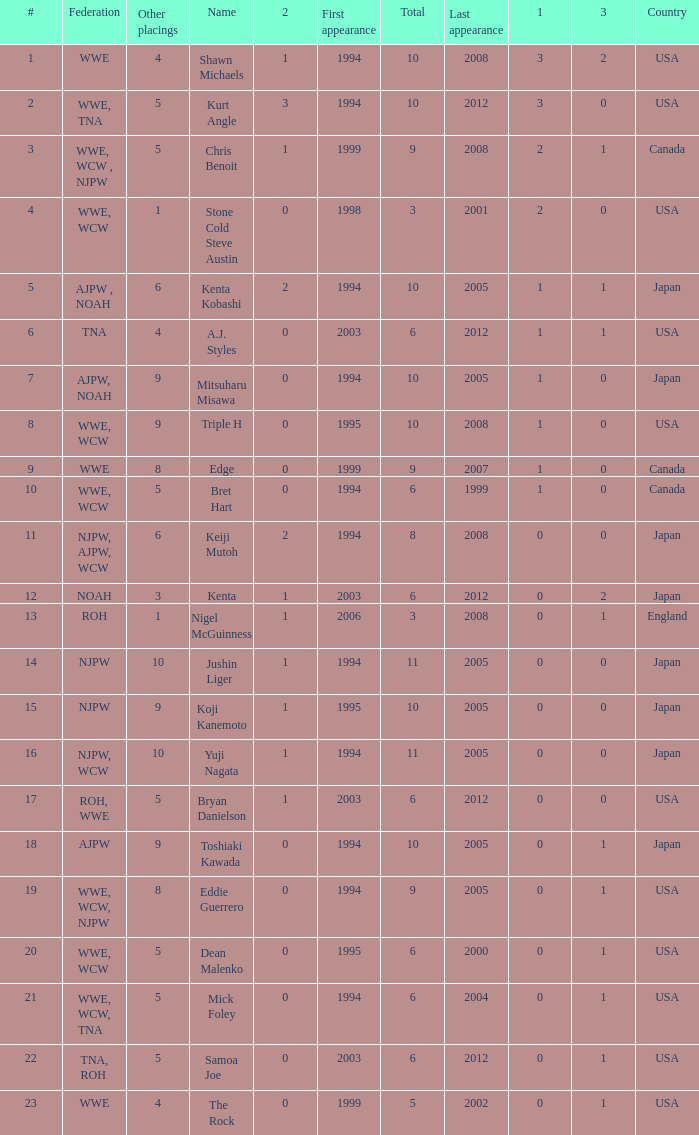How many times has a wrestler from the country of England wrestled in this event? 1.0. 